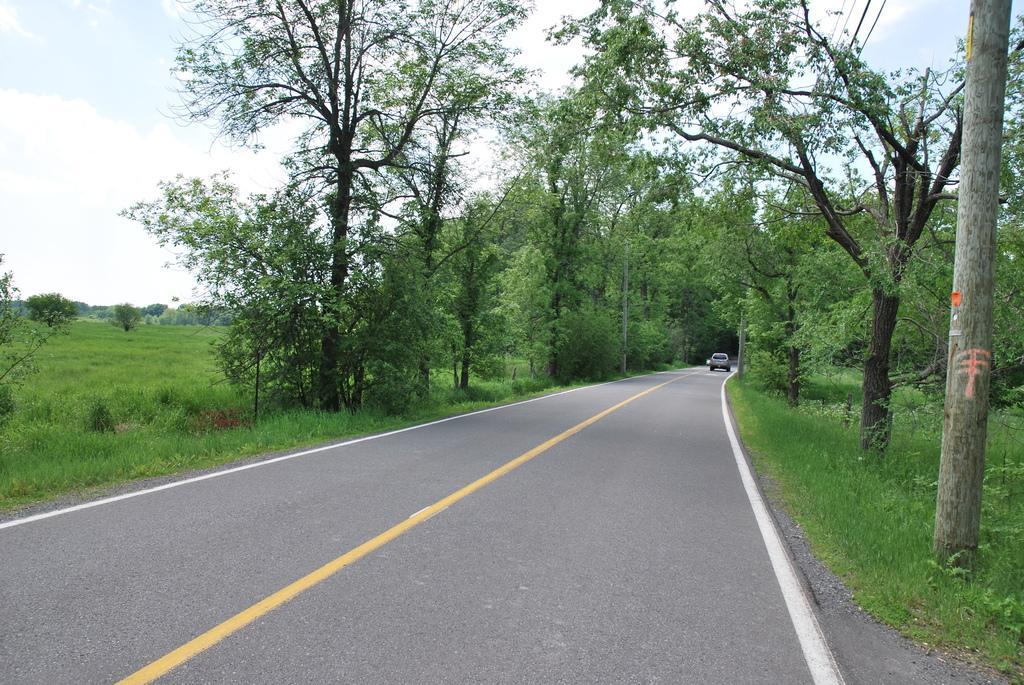Can you describe this image briefly? In this image there is the sky, there are trees, there is grass, there is a tree truncated towards the left of the image, there are poles, there are wires, there is road, there is a vehicle on the road. 